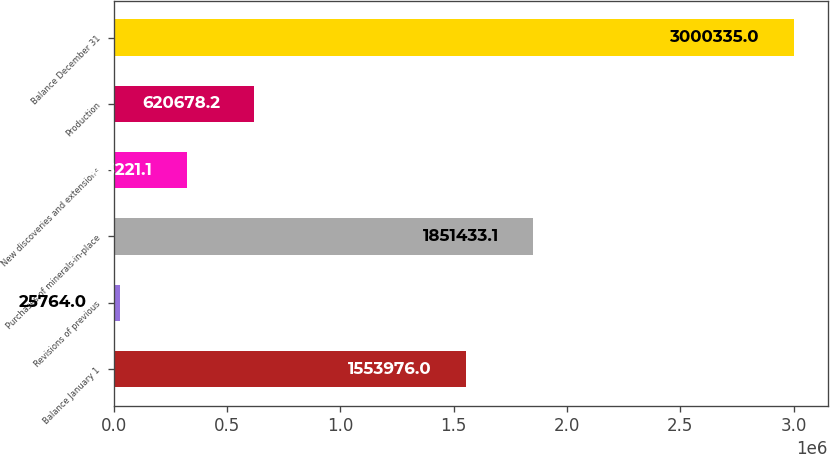Convert chart to OTSL. <chart><loc_0><loc_0><loc_500><loc_500><bar_chart><fcel>Balance January 1<fcel>Revisions of previous<fcel>Purchases of minerals-in-place<fcel>New discoveries and extensions<fcel>Production<fcel>Balance December 31<nl><fcel>1.55398e+06<fcel>25764<fcel>1.85143e+06<fcel>323221<fcel>620678<fcel>3.00034e+06<nl></chart> 